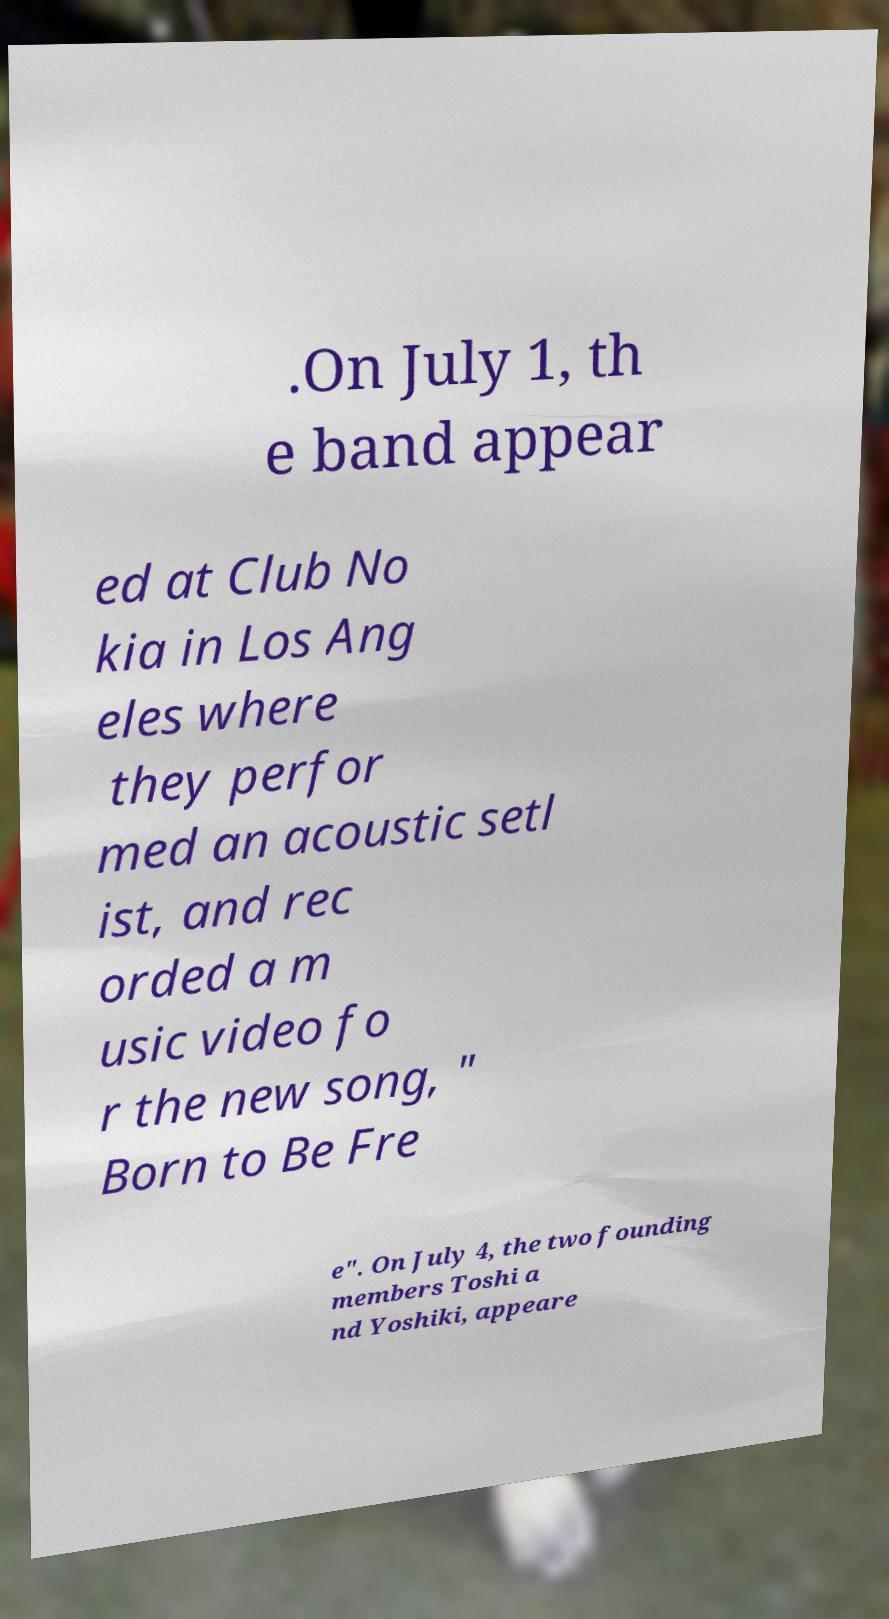There's text embedded in this image that I need extracted. Can you transcribe it verbatim? .On July 1, th e band appear ed at Club No kia in Los Ang eles where they perfor med an acoustic setl ist, and rec orded a m usic video fo r the new song, " Born to Be Fre e". On July 4, the two founding members Toshi a nd Yoshiki, appeare 